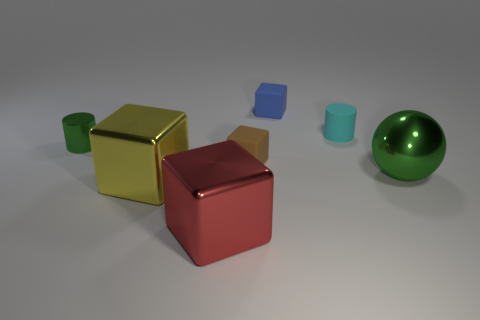How many cylinders are cyan matte objects or small green objects?
Offer a terse response. 2. What material is the blue object that is the same shape as the red object?
Your response must be concise. Rubber. The red object that is made of the same material as the large green thing is what size?
Your response must be concise. Large. Do the tiny matte object that is on the right side of the blue object and the matte object that is behind the tiny cyan rubber cylinder have the same shape?
Give a very brief answer. No. There is a tiny thing that is the same material as the red block; what is its color?
Your answer should be compact. Green. Does the metallic object that is right of the red metallic object have the same size as the yellow metallic object left of the cyan rubber object?
Offer a very short reply. Yes. There is a thing that is left of the red metallic object and in front of the tiny green cylinder; what shape is it?
Your response must be concise. Cube. Are there any tiny objects made of the same material as the green sphere?
Ensure brevity in your answer.  Yes. Does the object in front of the yellow metallic thing have the same material as the small cylinder that is on the right side of the large red metallic block?
Offer a very short reply. No. Is the number of large shiny blocks greater than the number of gray blocks?
Your response must be concise. Yes. 